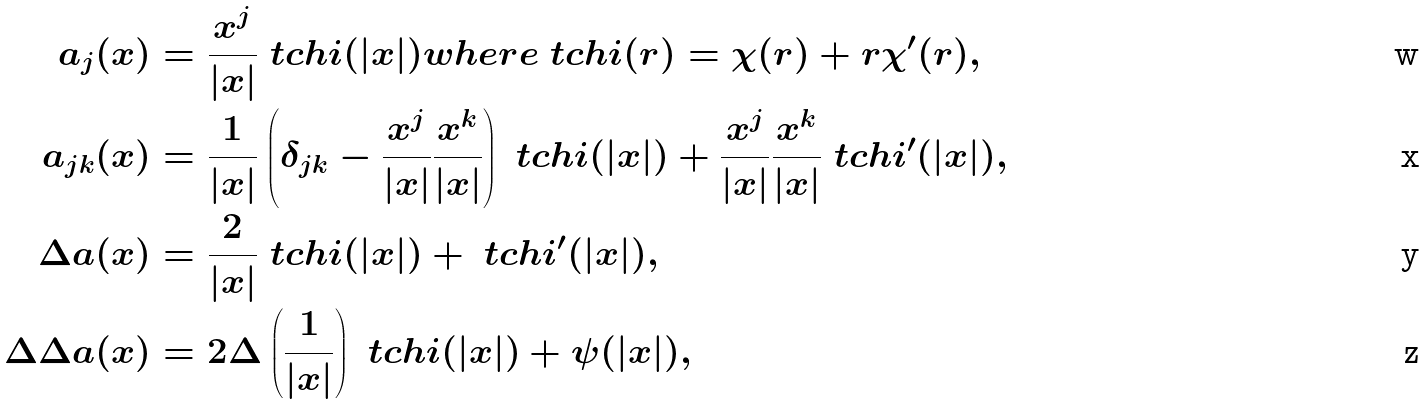<formula> <loc_0><loc_0><loc_500><loc_500>a _ { j } ( x ) & = \frac { x ^ { j } } { | x | } \ t c h i ( | x | ) { w h e r e } \ t c h i ( r ) = \chi ( r ) + r \chi ^ { \prime } ( r ) , \\ a _ { j k } ( x ) & = \frac { 1 } { | x | } \left ( \delta _ { j k } - \frac { x ^ { j } } { | x | } \frac { x ^ { k } } { | x | } \right ) \ t c h i ( | x | ) + \frac { x ^ { j } } { | x | } \frac { x ^ { k } } { | x | } \ t c h i ^ { \prime } ( | x | ) , \\ \Delta a ( x ) & = \frac { 2 } { | x | } \ t c h i ( | x | ) + \ t c h i ^ { \prime } ( | x | ) , \\ \Delta \Delta a ( x ) & = 2 \Delta \left ( \frac { 1 } { | x | } \right ) \ t c h i ( | x | ) + \psi ( | x | ) ,</formula> 